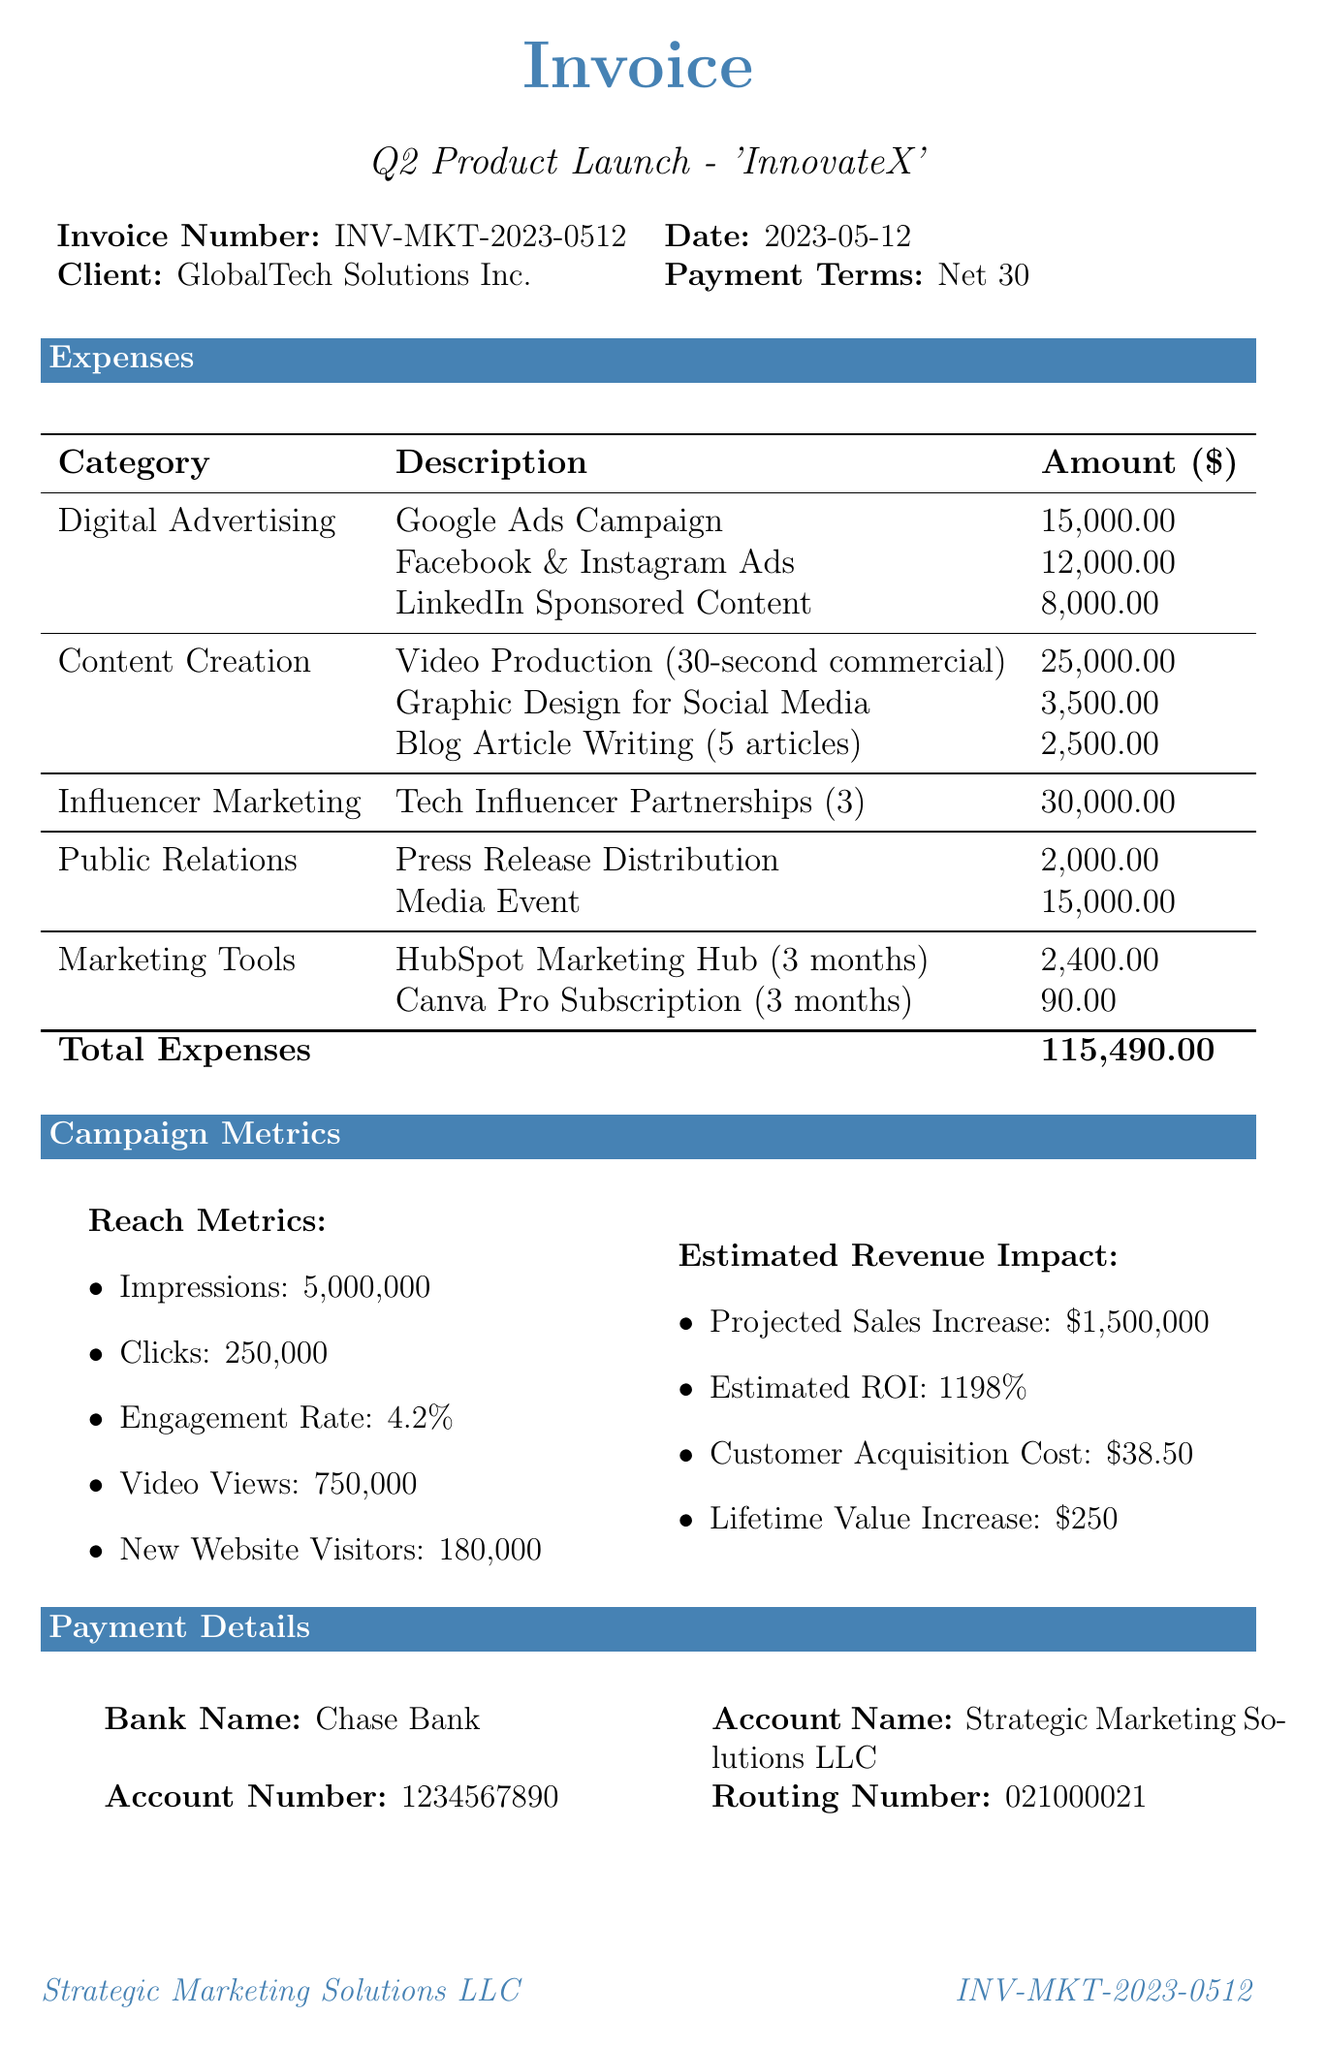what is the invoice number? The invoice number is a specific identifier provided at the top of the document.
Answer: INV-MKT-2023-0512 who is the client? The document states the name of the client for whom the marketing campaign was conducted.
Answer: GlobalTech Solutions Inc what is the total expense amount? The total expense amount is calculated as the sum of all listed expenses in the invoice.
Answer: 115490 how many impressions were generated during the campaign? The number of impressions is one of the reach metrics provided in the document.
Answer: 5000000 what is the estimated ROI? The estimated return on investment is calculated based on the projected revenue compared to the expenses.
Answer: 1198% how much was spent on digital advertising? The total digital advertising expense is aggregated from various advertising sources listed in the document.
Answer: 40000 what is the payment term specified in the invoice? The payment terms indicate how long the client has to pay the invoice.
Answer: Net 30 what is the projected sales increase? This figure represents the expected increase in sales as a result of the marketing campaign.
Answer: $1,500,000 what is the customer acquisition cost? The document provides a specific figure for the cost incurred to acquire each customer.
Answer: $38.50 